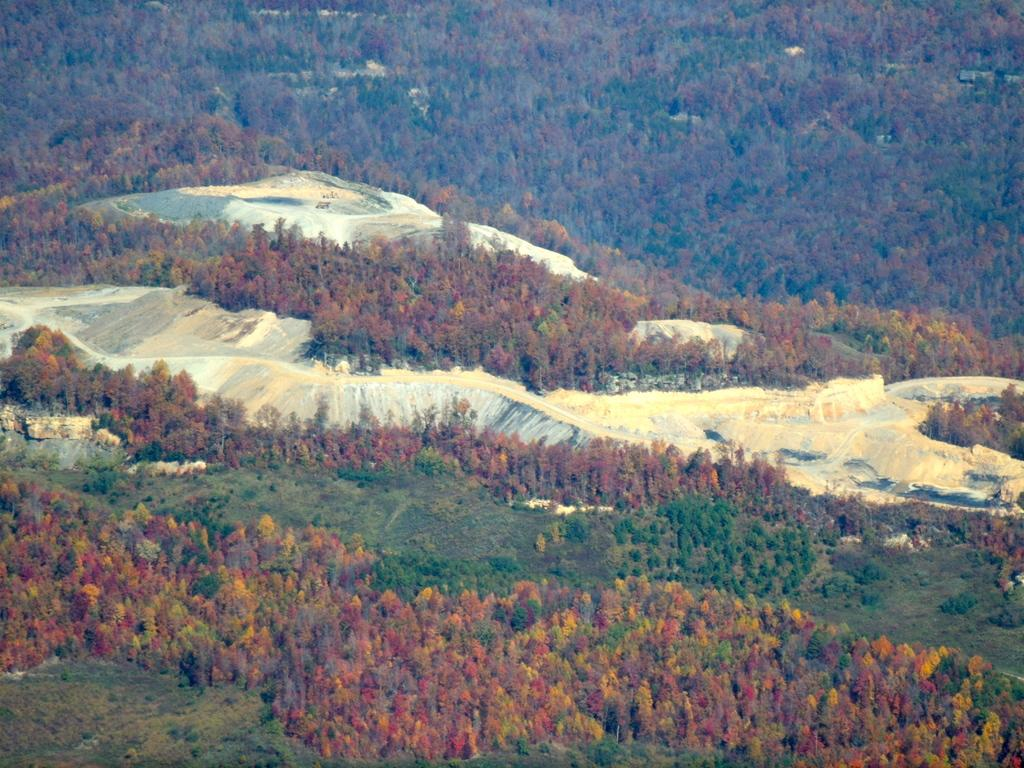What type of natural features can be seen in the image? There are trees and hills in the image. Can you describe the landscape in the image? The landscape features trees and hills. Where is the cave with the rare jewel in the image? There is no cave or rare jewel present in the image; it only features trees and hills. What type of polish is being used on the trees in the image? There is no polish being used on the trees in the image; they are natural trees in their original state. 